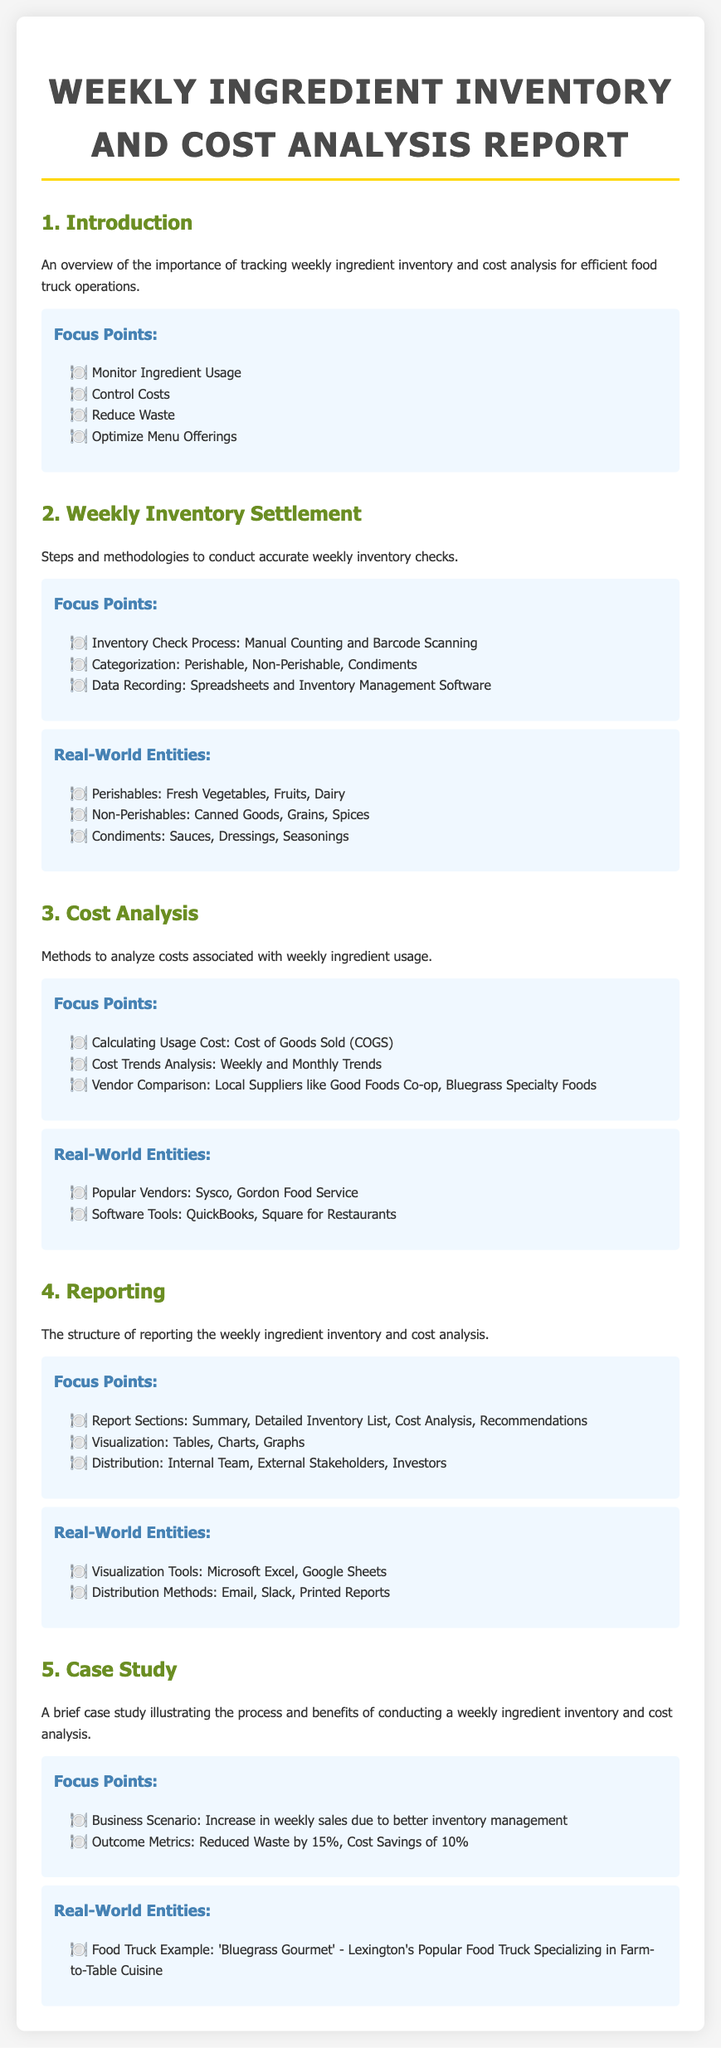What are the focus points of the introduction? The focus points listed in the introduction include monitoring ingredient usage, controlling costs, reducing waste, and optimizing menu offerings.
Answer: Monitor Ingredient Usage, Control Costs, Reduce Waste, Optimize Menu Offerings What is one method mentioned for conducting inventory checks? The document mentions manual counting and barcode scanning as methods for conducting inventory checks.
Answer: Manual Counting and Barcode Scanning Which vendors are listed for vendor comparison? The document identifies local suppliers like Good Foods Co-op and Bluegrass Specialty Foods for vendor comparison.
Answer: Good Foods Co-op, Bluegrass Specialty Foods What is the outcome metric mentioned for waste reduction? The document states that waste was reduced by 15% as an outcome metric in the case study.
Answer: Reduced Waste by 15% What tools are suggested for visualizing the inventory and cost report? Microsoft Excel and Google Sheets are identified as visualization tools in the document.
Answer: Microsoft Excel, Google Sheets What process is recommended for data recording during inventory checks? The document suggests using spreadsheets and inventory management software for data recording.
Answer: Spreadsheets and Inventory Management Software What was the business scenario described in the case study? The case study describes an increase in weekly sales due to better inventory management as the business scenario.
Answer: Increase in weekly sales due to better inventory management How are the report sections structured according to the document? The report sections are structured to include a summary, detailed inventory list, cost analysis, and recommendations.
Answer: Summary, Detailed Inventory List, Cost Analysis, Recommendations 